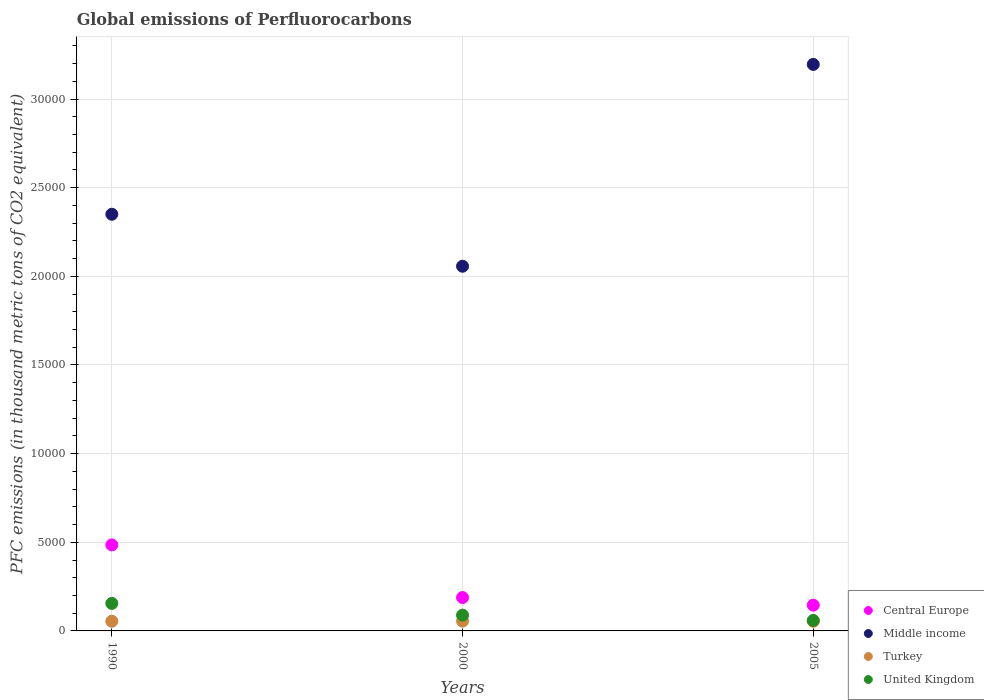What is the global emissions of Perfluorocarbons in Middle income in 1990?
Provide a succinct answer. 2.35e+04. Across all years, what is the maximum global emissions of Perfluorocarbons in Turkey?
Provide a succinct answer. 554.9. Across all years, what is the minimum global emissions of Perfluorocarbons in Central Europe?
Your response must be concise. 1453.6. In which year was the global emissions of Perfluorocarbons in United Kingdom maximum?
Your response must be concise. 1990. What is the total global emissions of Perfluorocarbons in United Kingdom in the graph?
Offer a terse response. 3034. What is the difference between the global emissions of Perfluorocarbons in Central Europe in 1990 and that in 2000?
Your response must be concise. 2965.7. What is the difference between the global emissions of Perfluorocarbons in Middle income in 2005 and the global emissions of Perfluorocarbons in Central Europe in 1990?
Provide a succinct answer. 2.71e+04. What is the average global emissions of Perfluorocarbons in Middle income per year?
Your answer should be compact. 2.53e+04. In the year 2005, what is the difference between the global emissions of Perfluorocarbons in United Kingdom and global emissions of Perfluorocarbons in Central Europe?
Make the answer very short. -862.2. In how many years, is the global emissions of Perfluorocarbons in Turkey greater than 4000 thousand metric tons?
Your response must be concise. 0. What is the ratio of the global emissions of Perfluorocarbons in Central Europe in 1990 to that in 2005?
Keep it short and to the point. 3.34. What is the difference between the highest and the second highest global emissions of Perfluorocarbons in Central Europe?
Keep it short and to the point. 2965.7. What is the difference between the highest and the lowest global emissions of Perfluorocarbons in Central Europe?
Give a very brief answer. 3396.8. In how many years, is the global emissions of Perfluorocarbons in Middle income greater than the average global emissions of Perfluorocarbons in Middle income taken over all years?
Provide a succinct answer. 1. Is the sum of the global emissions of Perfluorocarbons in Turkey in 1990 and 2000 greater than the maximum global emissions of Perfluorocarbons in United Kingdom across all years?
Your answer should be compact. No. Is it the case that in every year, the sum of the global emissions of Perfluorocarbons in United Kingdom and global emissions of Perfluorocarbons in Turkey  is greater than the global emissions of Perfluorocarbons in Middle income?
Give a very brief answer. No. Is the global emissions of Perfluorocarbons in Turkey strictly greater than the global emissions of Perfluorocarbons in Middle income over the years?
Offer a terse response. No. How many dotlines are there?
Your answer should be compact. 4. What is the difference between two consecutive major ticks on the Y-axis?
Offer a very short reply. 5000. Are the values on the major ticks of Y-axis written in scientific E-notation?
Give a very brief answer. No. Does the graph contain any zero values?
Give a very brief answer. No. Does the graph contain grids?
Ensure brevity in your answer.  Yes. Where does the legend appear in the graph?
Your answer should be very brief. Bottom right. What is the title of the graph?
Make the answer very short. Global emissions of Perfluorocarbons. What is the label or title of the Y-axis?
Make the answer very short. PFC emissions (in thousand metric tons of CO2 equivalent). What is the PFC emissions (in thousand metric tons of CO2 equivalent) of Central Europe in 1990?
Provide a succinct answer. 4850.4. What is the PFC emissions (in thousand metric tons of CO2 equivalent) of Middle income in 1990?
Provide a succinct answer. 2.35e+04. What is the PFC emissions (in thousand metric tons of CO2 equivalent) of Turkey in 1990?
Your answer should be very brief. 545.6. What is the PFC emissions (in thousand metric tons of CO2 equivalent) in United Kingdom in 1990?
Ensure brevity in your answer.  1552.5. What is the PFC emissions (in thousand metric tons of CO2 equivalent) of Central Europe in 2000?
Keep it short and to the point. 1884.7. What is the PFC emissions (in thousand metric tons of CO2 equivalent) in Middle income in 2000?
Your response must be concise. 2.06e+04. What is the PFC emissions (in thousand metric tons of CO2 equivalent) of Turkey in 2000?
Provide a succinct answer. 554.9. What is the PFC emissions (in thousand metric tons of CO2 equivalent) in United Kingdom in 2000?
Offer a terse response. 890.1. What is the PFC emissions (in thousand metric tons of CO2 equivalent) of Central Europe in 2005?
Ensure brevity in your answer.  1453.6. What is the PFC emissions (in thousand metric tons of CO2 equivalent) of Middle income in 2005?
Provide a succinct answer. 3.20e+04. What is the PFC emissions (in thousand metric tons of CO2 equivalent) in Turkey in 2005?
Give a very brief answer. 545.9. What is the PFC emissions (in thousand metric tons of CO2 equivalent) in United Kingdom in 2005?
Give a very brief answer. 591.4. Across all years, what is the maximum PFC emissions (in thousand metric tons of CO2 equivalent) of Central Europe?
Your answer should be very brief. 4850.4. Across all years, what is the maximum PFC emissions (in thousand metric tons of CO2 equivalent) of Middle income?
Your answer should be very brief. 3.20e+04. Across all years, what is the maximum PFC emissions (in thousand metric tons of CO2 equivalent) of Turkey?
Ensure brevity in your answer.  554.9. Across all years, what is the maximum PFC emissions (in thousand metric tons of CO2 equivalent) of United Kingdom?
Provide a succinct answer. 1552.5. Across all years, what is the minimum PFC emissions (in thousand metric tons of CO2 equivalent) in Central Europe?
Make the answer very short. 1453.6. Across all years, what is the minimum PFC emissions (in thousand metric tons of CO2 equivalent) of Middle income?
Offer a terse response. 2.06e+04. Across all years, what is the minimum PFC emissions (in thousand metric tons of CO2 equivalent) in Turkey?
Offer a terse response. 545.6. Across all years, what is the minimum PFC emissions (in thousand metric tons of CO2 equivalent) of United Kingdom?
Offer a terse response. 591.4. What is the total PFC emissions (in thousand metric tons of CO2 equivalent) of Central Europe in the graph?
Ensure brevity in your answer.  8188.7. What is the total PFC emissions (in thousand metric tons of CO2 equivalent) in Middle income in the graph?
Offer a very short reply. 7.60e+04. What is the total PFC emissions (in thousand metric tons of CO2 equivalent) of Turkey in the graph?
Provide a short and direct response. 1646.4. What is the total PFC emissions (in thousand metric tons of CO2 equivalent) of United Kingdom in the graph?
Offer a very short reply. 3034. What is the difference between the PFC emissions (in thousand metric tons of CO2 equivalent) in Central Europe in 1990 and that in 2000?
Offer a very short reply. 2965.7. What is the difference between the PFC emissions (in thousand metric tons of CO2 equivalent) in Middle income in 1990 and that in 2000?
Your answer should be very brief. 2931.5. What is the difference between the PFC emissions (in thousand metric tons of CO2 equivalent) of United Kingdom in 1990 and that in 2000?
Provide a short and direct response. 662.4. What is the difference between the PFC emissions (in thousand metric tons of CO2 equivalent) in Central Europe in 1990 and that in 2005?
Your answer should be very brief. 3396.8. What is the difference between the PFC emissions (in thousand metric tons of CO2 equivalent) in Middle income in 1990 and that in 2005?
Make the answer very short. -8451.4. What is the difference between the PFC emissions (in thousand metric tons of CO2 equivalent) in United Kingdom in 1990 and that in 2005?
Offer a terse response. 961.1. What is the difference between the PFC emissions (in thousand metric tons of CO2 equivalent) of Central Europe in 2000 and that in 2005?
Your answer should be compact. 431.1. What is the difference between the PFC emissions (in thousand metric tons of CO2 equivalent) of Middle income in 2000 and that in 2005?
Offer a terse response. -1.14e+04. What is the difference between the PFC emissions (in thousand metric tons of CO2 equivalent) of United Kingdom in 2000 and that in 2005?
Give a very brief answer. 298.7. What is the difference between the PFC emissions (in thousand metric tons of CO2 equivalent) in Central Europe in 1990 and the PFC emissions (in thousand metric tons of CO2 equivalent) in Middle income in 2000?
Your answer should be very brief. -1.57e+04. What is the difference between the PFC emissions (in thousand metric tons of CO2 equivalent) of Central Europe in 1990 and the PFC emissions (in thousand metric tons of CO2 equivalent) of Turkey in 2000?
Give a very brief answer. 4295.5. What is the difference between the PFC emissions (in thousand metric tons of CO2 equivalent) of Central Europe in 1990 and the PFC emissions (in thousand metric tons of CO2 equivalent) of United Kingdom in 2000?
Your answer should be very brief. 3960.3. What is the difference between the PFC emissions (in thousand metric tons of CO2 equivalent) in Middle income in 1990 and the PFC emissions (in thousand metric tons of CO2 equivalent) in Turkey in 2000?
Provide a succinct answer. 2.29e+04. What is the difference between the PFC emissions (in thousand metric tons of CO2 equivalent) in Middle income in 1990 and the PFC emissions (in thousand metric tons of CO2 equivalent) in United Kingdom in 2000?
Your answer should be very brief. 2.26e+04. What is the difference between the PFC emissions (in thousand metric tons of CO2 equivalent) in Turkey in 1990 and the PFC emissions (in thousand metric tons of CO2 equivalent) in United Kingdom in 2000?
Your answer should be very brief. -344.5. What is the difference between the PFC emissions (in thousand metric tons of CO2 equivalent) in Central Europe in 1990 and the PFC emissions (in thousand metric tons of CO2 equivalent) in Middle income in 2005?
Offer a very short reply. -2.71e+04. What is the difference between the PFC emissions (in thousand metric tons of CO2 equivalent) of Central Europe in 1990 and the PFC emissions (in thousand metric tons of CO2 equivalent) of Turkey in 2005?
Make the answer very short. 4304.5. What is the difference between the PFC emissions (in thousand metric tons of CO2 equivalent) of Central Europe in 1990 and the PFC emissions (in thousand metric tons of CO2 equivalent) of United Kingdom in 2005?
Your answer should be very brief. 4259. What is the difference between the PFC emissions (in thousand metric tons of CO2 equivalent) of Middle income in 1990 and the PFC emissions (in thousand metric tons of CO2 equivalent) of Turkey in 2005?
Your answer should be very brief. 2.30e+04. What is the difference between the PFC emissions (in thousand metric tons of CO2 equivalent) in Middle income in 1990 and the PFC emissions (in thousand metric tons of CO2 equivalent) in United Kingdom in 2005?
Offer a very short reply. 2.29e+04. What is the difference between the PFC emissions (in thousand metric tons of CO2 equivalent) of Turkey in 1990 and the PFC emissions (in thousand metric tons of CO2 equivalent) of United Kingdom in 2005?
Provide a short and direct response. -45.8. What is the difference between the PFC emissions (in thousand metric tons of CO2 equivalent) in Central Europe in 2000 and the PFC emissions (in thousand metric tons of CO2 equivalent) in Middle income in 2005?
Keep it short and to the point. -3.01e+04. What is the difference between the PFC emissions (in thousand metric tons of CO2 equivalent) in Central Europe in 2000 and the PFC emissions (in thousand metric tons of CO2 equivalent) in Turkey in 2005?
Provide a succinct answer. 1338.8. What is the difference between the PFC emissions (in thousand metric tons of CO2 equivalent) in Central Europe in 2000 and the PFC emissions (in thousand metric tons of CO2 equivalent) in United Kingdom in 2005?
Give a very brief answer. 1293.3. What is the difference between the PFC emissions (in thousand metric tons of CO2 equivalent) of Middle income in 2000 and the PFC emissions (in thousand metric tons of CO2 equivalent) of Turkey in 2005?
Your answer should be very brief. 2.00e+04. What is the difference between the PFC emissions (in thousand metric tons of CO2 equivalent) in Middle income in 2000 and the PFC emissions (in thousand metric tons of CO2 equivalent) in United Kingdom in 2005?
Keep it short and to the point. 2.00e+04. What is the difference between the PFC emissions (in thousand metric tons of CO2 equivalent) in Turkey in 2000 and the PFC emissions (in thousand metric tons of CO2 equivalent) in United Kingdom in 2005?
Ensure brevity in your answer.  -36.5. What is the average PFC emissions (in thousand metric tons of CO2 equivalent) in Central Europe per year?
Make the answer very short. 2729.57. What is the average PFC emissions (in thousand metric tons of CO2 equivalent) of Middle income per year?
Your answer should be compact. 2.53e+04. What is the average PFC emissions (in thousand metric tons of CO2 equivalent) of Turkey per year?
Offer a very short reply. 548.8. What is the average PFC emissions (in thousand metric tons of CO2 equivalent) of United Kingdom per year?
Your answer should be very brief. 1011.33. In the year 1990, what is the difference between the PFC emissions (in thousand metric tons of CO2 equivalent) of Central Europe and PFC emissions (in thousand metric tons of CO2 equivalent) of Middle income?
Keep it short and to the point. -1.87e+04. In the year 1990, what is the difference between the PFC emissions (in thousand metric tons of CO2 equivalent) in Central Europe and PFC emissions (in thousand metric tons of CO2 equivalent) in Turkey?
Provide a short and direct response. 4304.8. In the year 1990, what is the difference between the PFC emissions (in thousand metric tons of CO2 equivalent) in Central Europe and PFC emissions (in thousand metric tons of CO2 equivalent) in United Kingdom?
Your answer should be very brief. 3297.9. In the year 1990, what is the difference between the PFC emissions (in thousand metric tons of CO2 equivalent) of Middle income and PFC emissions (in thousand metric tons of CO2 equivalent) of Turkey?
Give a very brief answer. 2.30e+04. In the year 1990, what is the difference between the PFC emissions (in thousand metric tons of CO2 equivalent) in Middle income and PFC emissions (in thousand metric tons of CO2 equivalent) in United Kingdom?
Your answer should be very brief. 2.19e+04. In the year 1990, what is the difference between the PFC emissions (in thousand metric tons of CO2 equivalent) in Turkey and PFC emissions (in thousand metric tons of CO2 equivalent) in United Kingdom?
Ensure brevity in your answer.  -1006.9. In the year 2000, what is the difference between the PFC emissions (in thousand metric tons of CO2 equivalent) in Central Europe and PFC emissions (in thousand metric tons of CO2 equivalent) in Middle income?
Give a very brief answer. -1.87e+04. In the year 2000, what is the difference between the PFC emissions (in thousand metric tons of CO2 equivalent) in Central Europe and PFC emissions (in thousand metric tons of CO2 equivalent) in Turkey?
Your answer should be compact. 1329.8. In the year 2000, what is the difference between the PFC emissions (in thousand metric tons of CO2 equivalent) in Central Europe and PFC emissions (in thousand metric tons of CO2 equivalent) in United Kingdom?
Give a very brief answer. 994.6. In the year 2000, what is the difference between the PFC emissions (in thousand metric tons of CO2 equivalent) in Middle income and PFC emissions (in thousand metric tons of CO2 equivalent) in Turkey?
Your answer should be compact. 2.00e+04. In the year 2000, what is the difference between the PFC emissions (in thousand metric tons of CO2 equivalent) of Middle income and PFC emissions (in thousand metric tons of CO2 equivalent) of United Kingdom?
Keep it short and to the point. 1.97e+04. In the year 2000, what is the difference between the PFC emissions (in thousand metric tons of CO2 equivalent) of Turkey and PFC emissions (in thousand metric tons of CO2 equivalent) of United Kingdom?
Offer a terse response. -335.2. In the year 2005, what is the difference between the PFC emissions (in thousand metric tons of CO2 equivalent) of Central Europe and PFC emissions (in thousand metric tons of CO2 equivalent) of Middle income?
Ensure brevity in your answer.  -3.05e+04. In the year 2005, what is the difference between the PFC emissions (in thousand metric tons of CO2 equivalent) of Central Europe and PFC emissions (in thousand metric tons of CO2 equivalent) of Turkey?
Offer a terse response. 907.7. In the year 2005, what is the difference between the PFC emissions (in thousand metric tons of CO2 equivalent) in Central Europe and PFC emissions (in thousand metric tons of CO2 equivalent) in United Kingdom?
Offer a very short reply. 862.2. In the year 2005, what is the difference between the PFC emissions (in thousand metric tons of CO2 equivalent) of Middle income and PFC emissions (in thousand metric tons of CO2 equivalent) of Turkey?
Ensure brevity in your answer.  3.14e+04. In the year 2005, what is the difference between the PFC emissions (in thousand metric tons of CO2 equivalent) of Middle income and PFC emissions (in thousand metric tons of CO2 equivalent) of United Kingdom?
Keep it short and to the point. 3.14e+04. In the year 2005, what is the difference between the PFC emissions (in thousand metric tons of CO2 equivalent) in Turkey and PFC emissions (in thousand metric tons of CO2 equivalent) in United Kingdom?
Keep it short and to the point. -45.5. What is the ratio of the PFC emissions (in thousand metric tons of CO2 equivalent) in Central Europe in 1990 to that in 2000?
Your answer should be compact. 2.57. What is the ratio of the PFC emissions (in thousand metric tons of CO2 equivalent) of Middle income in 1990 to that in 2000?
Keep it short and to the point. 1.14. What is the ratio of the PFC emissions (in thousand metric tons of CO2 equivalent) of Turkey in 1990 to that in 2000?
Make the answer very short. 0.98. What is the ratio of the PFC emissions (in thousand metric tons of CO2 equivalent) of United Kingdom in 1990 to that in 2000?
Your answer should be very brief. 1.74. What is the ratio of the PFC emissions (in thousand metric tons of CO2 equivalent) of Central Europe in 1990 to that in 2005?
Your answer should be very brief. 3.34. What is the ratio of the PFC emissions (in thousand metric tons of CO2 equivalent) in Middle income in 1990 to that in 2005?
Keep it short and to the point. 0.74. What is the ratio of the PFC emissions (in thousand metric tons of CO2 equivalent) in United Kingdom in 1990 to that in 2005?
Provide a short and direct response. 2.63. What is the ratio of the PFC emissions (in thousand metric tons of CO2 equivalent) in Central Europe in 2000 to that in 2005?
Offer a very short reply. 1.3. What is the ratio of the PFC emissions (in thousand metric tons of CO2 equivalent) in Middle income in 2000 to that in 2005?
Your response must be concise. 0.64. What is the ratio of the PFC emissions (in thousand metric tons of CO2 equivalent) of Turkey in 2000 to that in 2005?
Make the answer very short. 1.02. What is the ratio of the PFC emissions (in thousand metric tons of CO2 equivalent) of United Kingdom in 2000 to that in 2005?
Offer a very short reply. 1.51. What is the difference between the highest and the second highest PFC emissions (in thousand metric tons of CO2 equivalent) in Central Europe?
Offer a terse response. 2965.7. What is the difference between the highest and the second highest PFC emissions (in thousand metric tons of CO2 equivalent) of Middle income?
Make the answer very short. 8451.4. What is the difference between the highest and the second highest PFC emissions (in thousand metric tons of CO2 equivalent) in Turkey?
Provide a short and direct response. 9. What is the difference between the highest and the second highest PFC emissions (in thousand metric tons of CO2 equivalent) of United Kingdom?
Provide a short and direct response. 662.4. What is the difference between the highest and the lowest PFC emissions (in thousand metric tons of CO2 equivalent) of Central Europe?
Your answer should be compact. 3396.8. What is the difference between the highest and the lowest PFC emissions (in thousand metric tons of CO2 equivalent) of Middle income?
Your answer should be very brief. 1.14e+04. What is the difference between the highest and the lowest PFC emissions (in thousand metric tons of CO2 equivalent) of Turkey?
Your response must be concise. 9.3. What is the difference between the highest and the lowest PFC emissions (in thousand metric tons of CO2 equivalent) in United Kingdom?
Give a very brief answer. 961.1. 